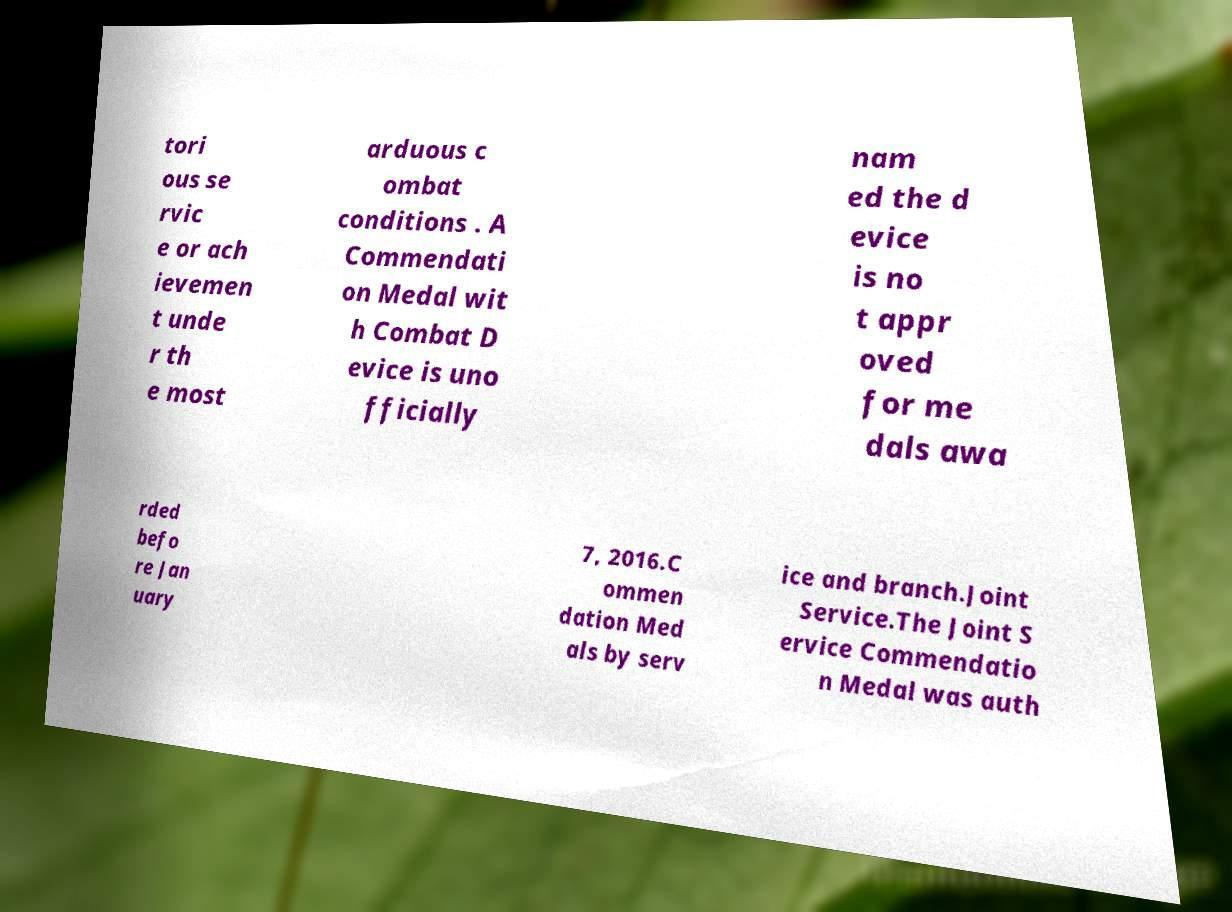I need the written content from this picture converted into text. Can you do that? tori ous se rvic e or ach ievemen t unde r th e most arduous c ombat conditions . A Commendati on Medal wit h Combat D evice is uno fficially nam ed the d evice is no t appr oved for me dals awa rded befo re Jan uary 7, 2016.C ommen dation Med als by serv ice and branch.Joint Service.The Joint S ervice Commendatio n Medal was auth 